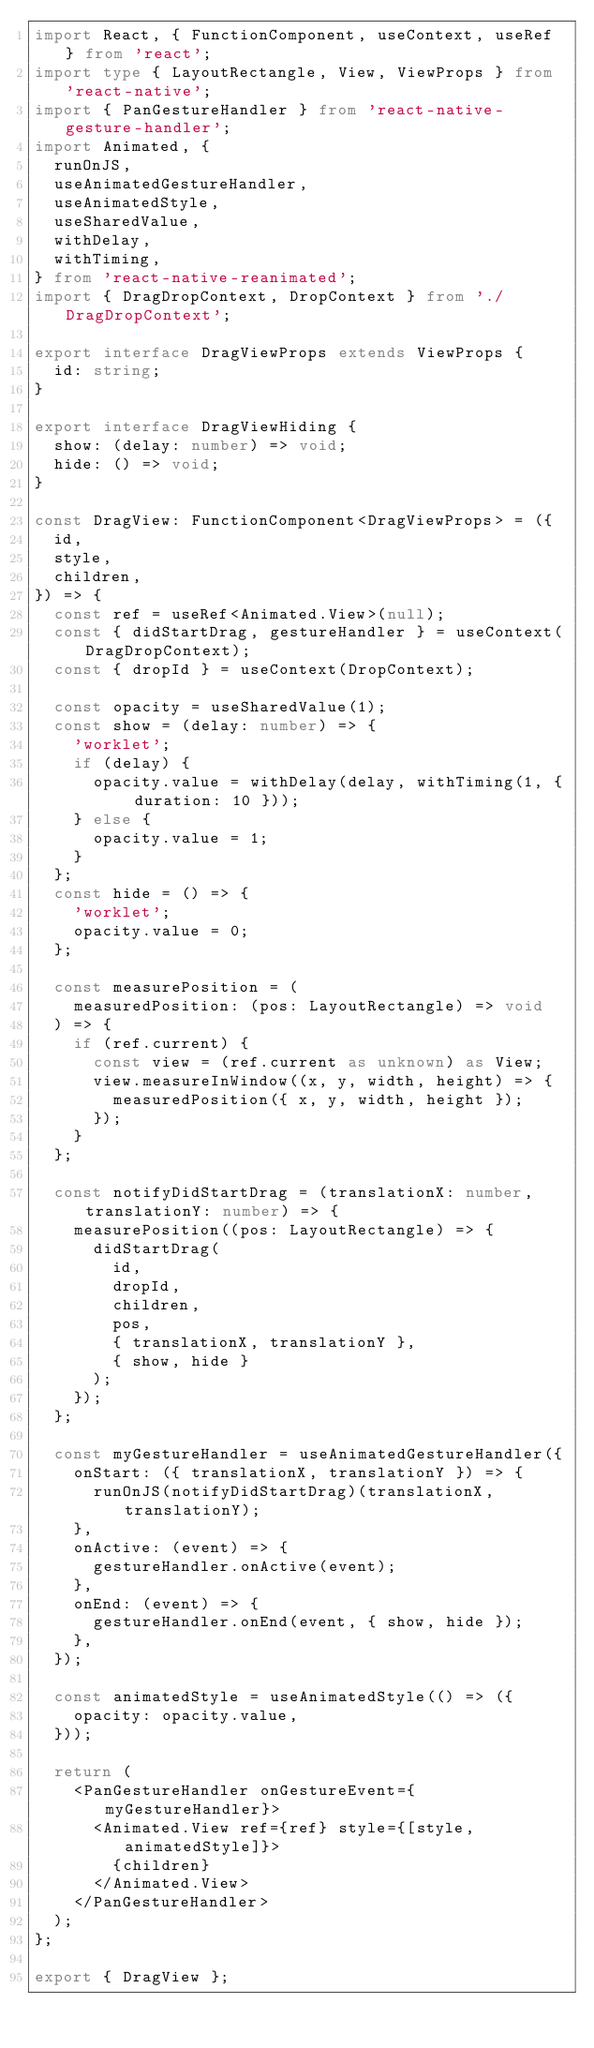Convert code to text. <code><loc_0><loc_0><loc_500><loc_500><_TypeScript_>import React, { FunctionComponent, useContext, useRef } from 'react';
import type { LayoutRectangle, View, ViewProps } from 'react-native';
import { PanGestureHandler } from 'react-native-gesture-handler';
import Animated, {
  runOnJS,
  useAnimatedGestureHandler,
  useAnimatedStyle,
  useSharedValue,
  withDelay,
  withTiming,
} from 'react-native-reanimated';
import { DragDropContext, DropContext } from './DragDropContext';

export interface DragViewProps extends ViewProps {
  id: string;
}

export interface DragViewHiding {
  show: (delay: number) => void;
  hide: () => void;
}

const DragView: FunctionComponent<DragViewProps> = ({
  id,
  style,
  children,
}) => {
  const ref = useRef<Animated.View>(null);
  const { didStartDrag, gestureHandler } = useContext(DragDropContext);
  const { dropId } = useContext(DropContext);

  const opacity = useSharedValue(1);
  const show = (delay: number) => {
    'worklet';
    if (delay) {
      opacity.value = withDelay(delay, withTiming(1, { duration: 10 }));
    } else {
      opacity.value = 1;
    }
  };
  const hide = () => {
    'worklet';
    opacity.value = 0;
  };

  const measurePosition = (
    measuredPosition: (pos: LayoutRectangle) => void
  ) => {
    if (ref.current) {
      const view = (ref.current as unknown) as View;
      view.measureInWindow((x, y, width, height) => {
        measuredPosition({ x, y, width, height });
      });
    }
  };

  const notifyDidStartDrag = (translationX: number, translationY: number) => {
    measurePosition((pos: LayoutRectangle) => {
      didStartDrag(
        id,
        dropId,
        children,
        pos,
        { translationX, translationY },
        { show, hide }
      );
    });
  };

  const myGestureHandler = useAnimatedGestureHandler({
    onStart: ({ translationX, translationY }) => {
      runOnJS(notifyDidStartDrag)(translationX, translationY);
    },
    onActive: (event) => {
      gestureHandler.onActive(event);
    },
    onEnd: (event) => {
      gestureHandler.onEnd(event, { show, hide });
    },
  });

  const animatedStyle = useAnimatedStyle(() => ({
    opacity: opacity.value,
  }));

  return (
    <PanGestureHandler onGestureEvent={myGestureHandler}>
      <Animated.View ref={ref} style={[style, animatedStyle]}>
        {children}
      </Animated.View>
    </PanGestureHandler>
  );
};

export { DragView };
</code> 